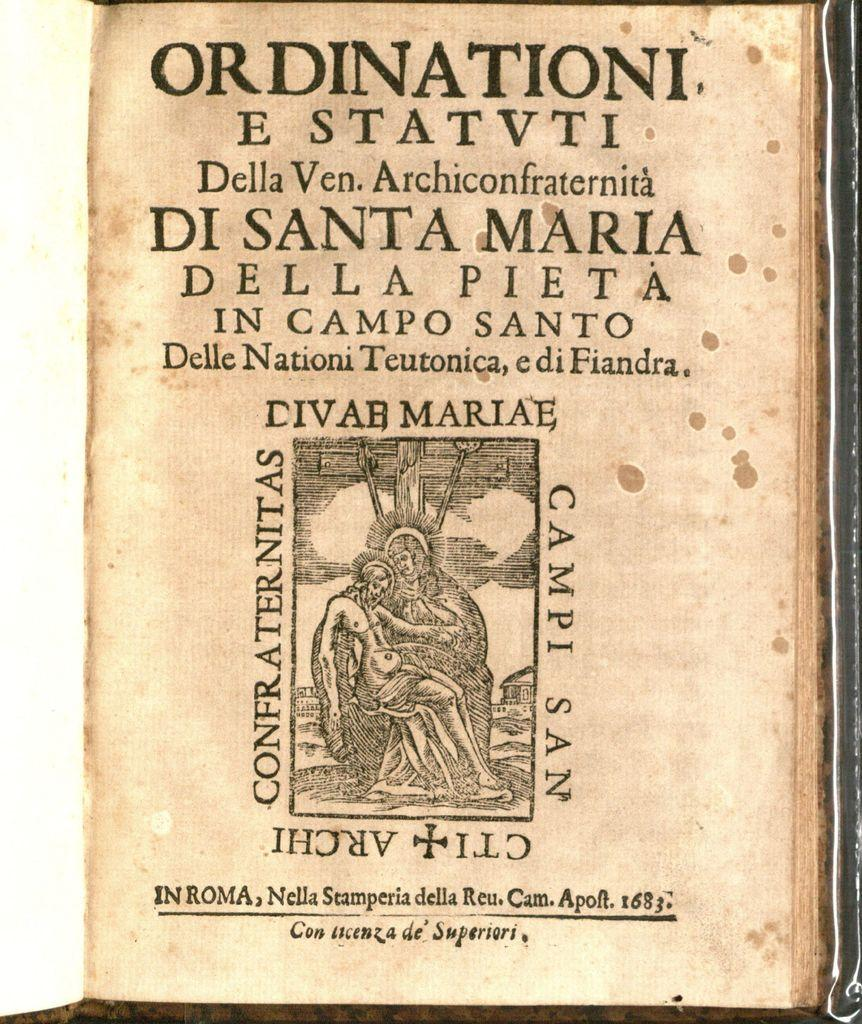<image>
Relay a brief, clear account of the picture shown. The opening page of the Ordinationi E Statvti Della Ven. Archiconfraternita 